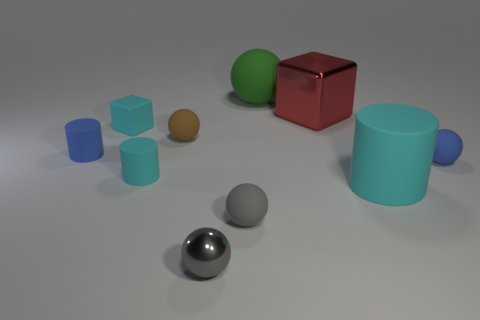What number of matte things are blocks or red blocks?
Your answer should be very brief. 1. Is the number of big green rubber spheres less than the number of big cyan spheres?
Your answer should be very brief. No. Do the brown rubber ball and the cyan object to the left of the small cyan rubber cylinder have the same size?
Offer a terse response. Yes. Is there anything else that has the same shape as the green matte object?
Offer a terse response. Yes. The gray shiny sphere is what size?
Your answer should be compact. Small. Are there fewer tiny gray things that are to the right of the tiny shiny ball than big rubber things?
Provide a succinct answer. Yes. Is the gray matte ball the same size as the gray metallic object?
Provide a succinct answer. Yes. There is a ball that is the same material as the large block; what color is it?
Offer a terse response. Gray. Are there fewer brown matte balls in front of the cyan cube than blue cylinders that are on the right side of the big green matte thing?
Your answer should be very brief. No. What number of big balls are the same color as the tiny block?
Your answer should be compact. 0. 